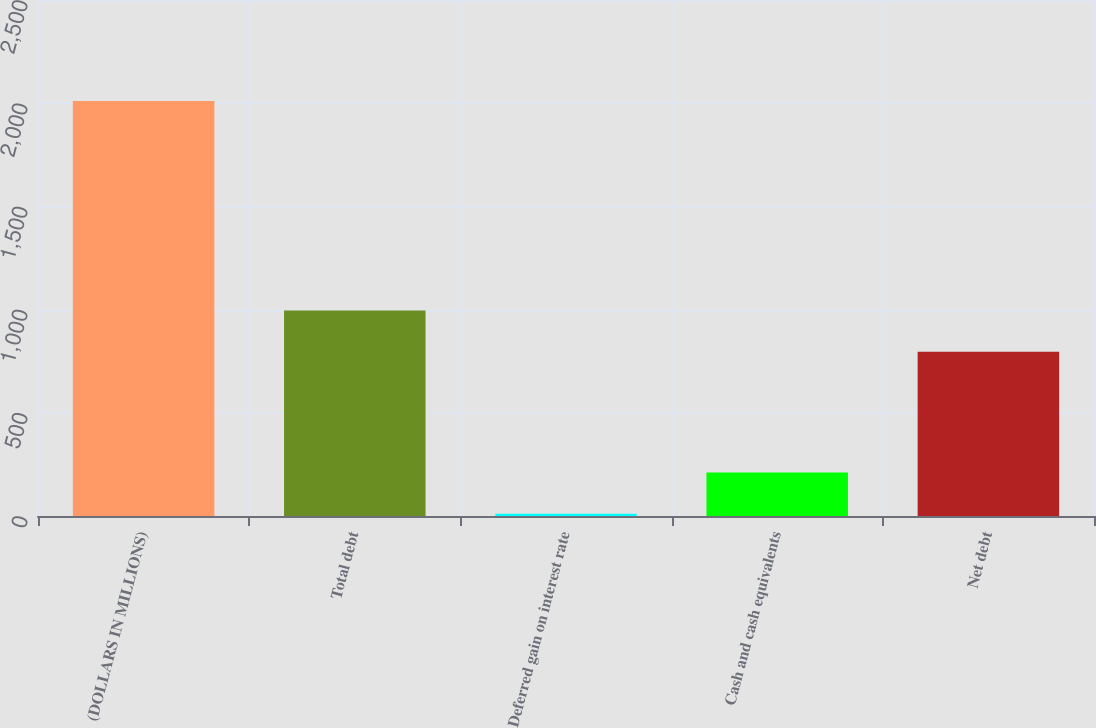<chart> <loc_0><loc_0><loc_500><loc_500><bar_chart><fcel>(DOLLARS IN MILLIONS)<fcel>Total debt<fcel>Deferred gain on interest rate<fcel>Cash and cash equivalents<fcel>Net debt<nl><fcel>2011<fcel>995.6<fcel>11<fcel>211<fcel>795.6<nl></chart> 